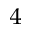<formula> <loc_0><loc_0><loc_500><loc_500>^ { 4 }</formula> 